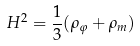Convert formula to latex. <formula><loc_0><loc_0><loc_500><loc_500>H ^ { 2 } = \frac { 1 } { 3 } ( \rho _ { \varphi } + \rho _ { m } )</formula> 